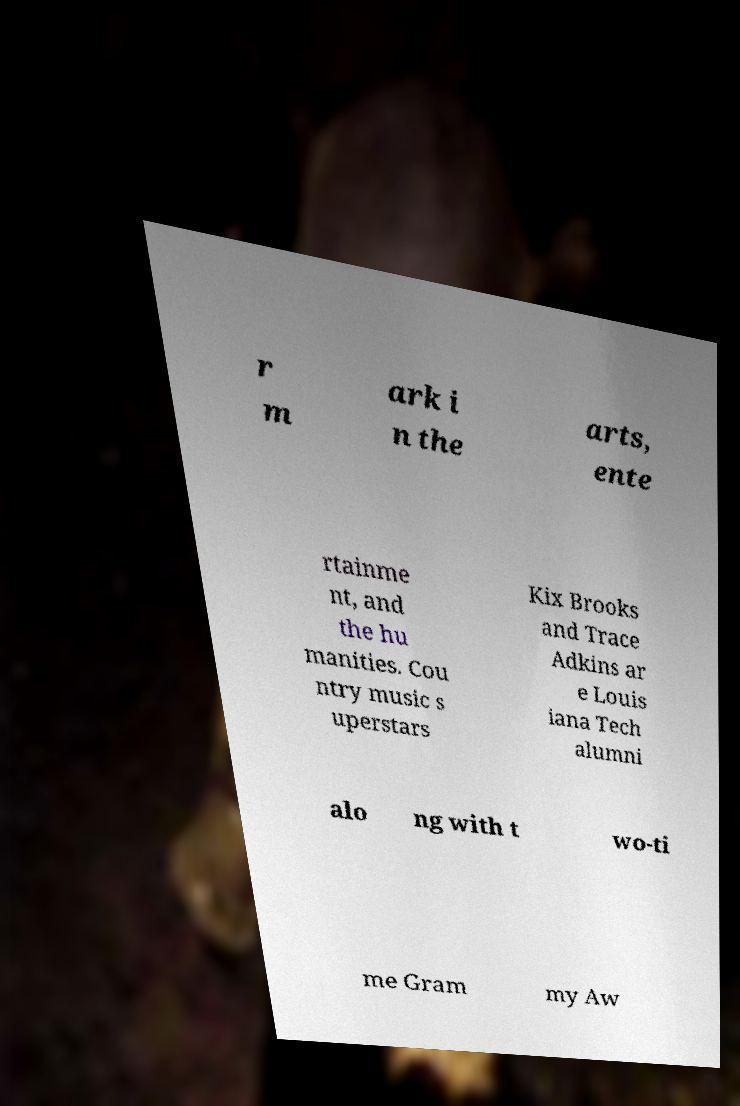Please read and relay the text visible in this image. What does it say? r m ark i n the arts, ente rtainme nt, and the hu manities. Cou ntry music s uperstars Kix Brooks and Trace Adkins ar e Louis iana Tech alumni alo ng with t wo-ti me Gram my Aw 